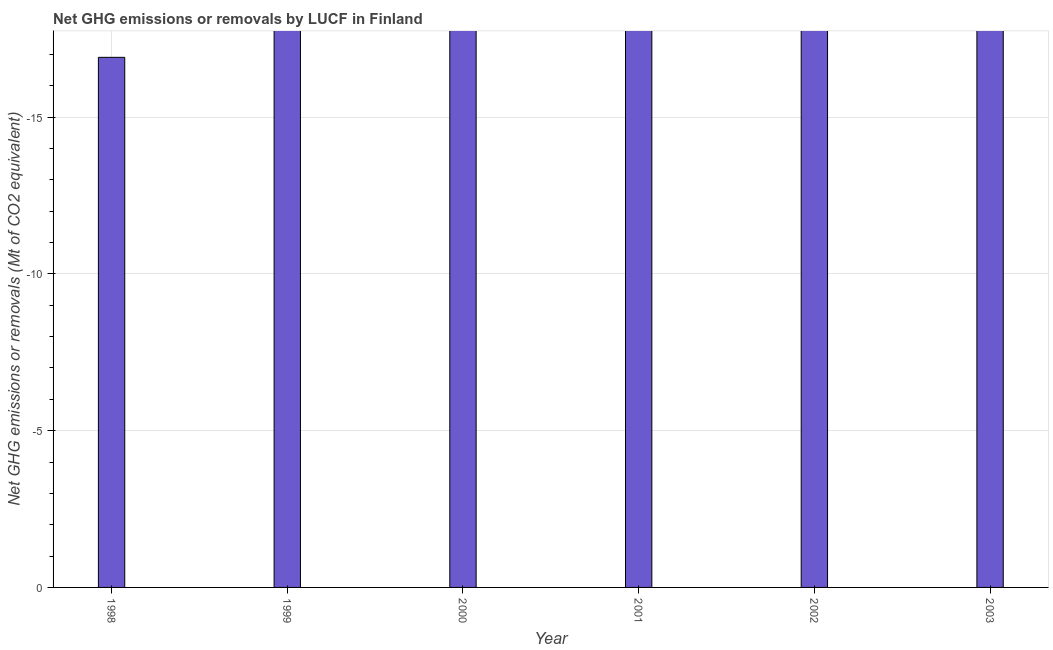Does the graph contain any zero values?
Offer a terse response. Yes. Does the graph contain grids?
Offer a terse response. Yes. What is the title of the graph?
Offer a terse response. Net GHG emissions or removals by LUCF in Finland. What is the label or title of the X-axis?
Keep it short and to the point. Year. What is the label or title of the Y-axis?
Ensure brevity in your answer.  Net GHG emissions or removals (Mt of CO2 equivalent). What is the ghg net emissions or removals in 2003?
Your response must be concise. 0. In how many years, is the ghg net emissions or removals greater than -6 Mt?
Your answer should be very brief. 0. How many years are there in the graph?
Provide a short and direct response. 6. What is the difference between two consecutive major ticks on the Y-axis?
Provide a short and direct response. 5. Are the values on the major ticks of Y-axis written in scientific E-notation?
Give a very brief answer. No. 